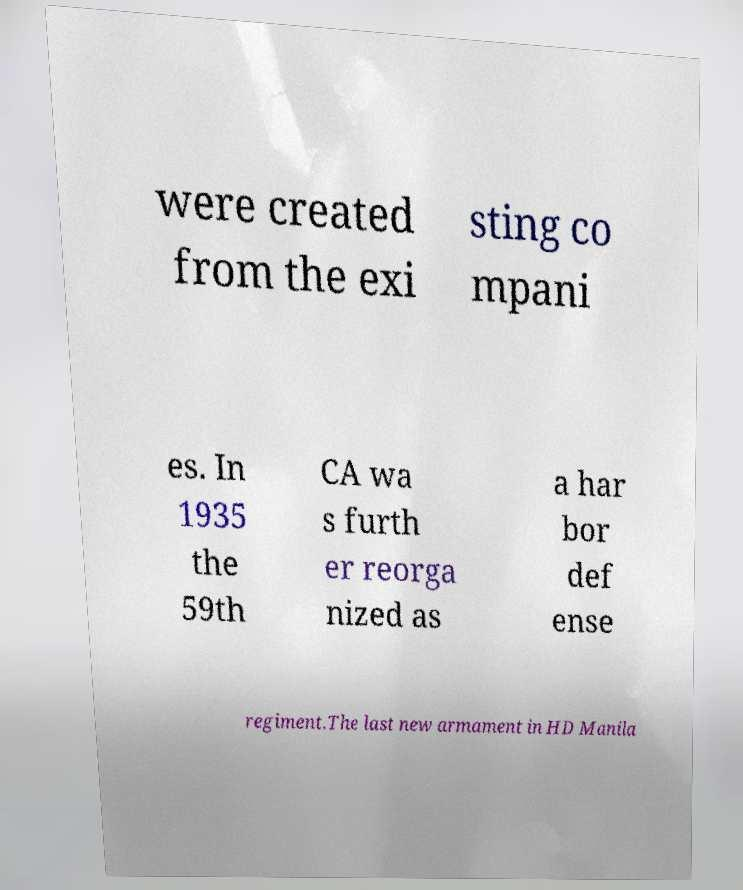For documentation purposes, I need the text within this image transcribed. Could you provide that? were created from the exi sting co mpani es. In 1935 the 59th CA wa s furth er reorga nized as a har bor def ense regiment.The last new armament in HD Manila 